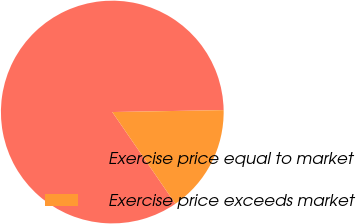<chart> <loc_0><loc_0><loc_500><loc_500><pie_chart><fcel>Exercise price equal to market<fcel>Exercise price exceeds market<nl><fcel>84.31%<fcel>15.69%<nl></chart> 